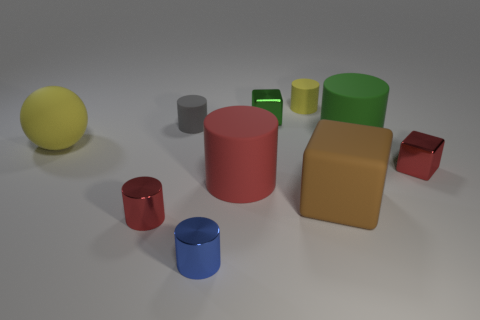Are there the same number of metallic objects in front of the big yellow object and things that are on the left side of the tiny blue metal cylinder?
Your response must be concise. Yes. What is the material of the brown block?
Your answer should be very brief. Rubber. What is the material of the small yellow object on the left side of the large brown thing?
Offer a terse response. Rubber. Is the number of small red metallic things that are left of the tiny red cube greater than the number of red rubber blocks?
Your response must be concise. Yes. Is there a brown object that is behind the red shiny cube in front of the tiny rubber object to the left of the yellow rubber cylinder?
Your answer should be compact. No. Are there any small red objects in front of the big brown rubber object?
Your answer should be very brief. Yes. What number of matte objects have the same color as the big ball?
Your response must be concise. 1. There is a blue cylinder that is the same material as the green cube; what size is it?
Provide a succinct answer. Small. What size is the yellow object in front of the tiny block behind the small metal cube in front of the tiny gray cylinder?
Offer a terse response. Large. There is a rubber cylinder that is in front of the yellow rubber ball; how big is it?
Offer a very short reply. Large. 